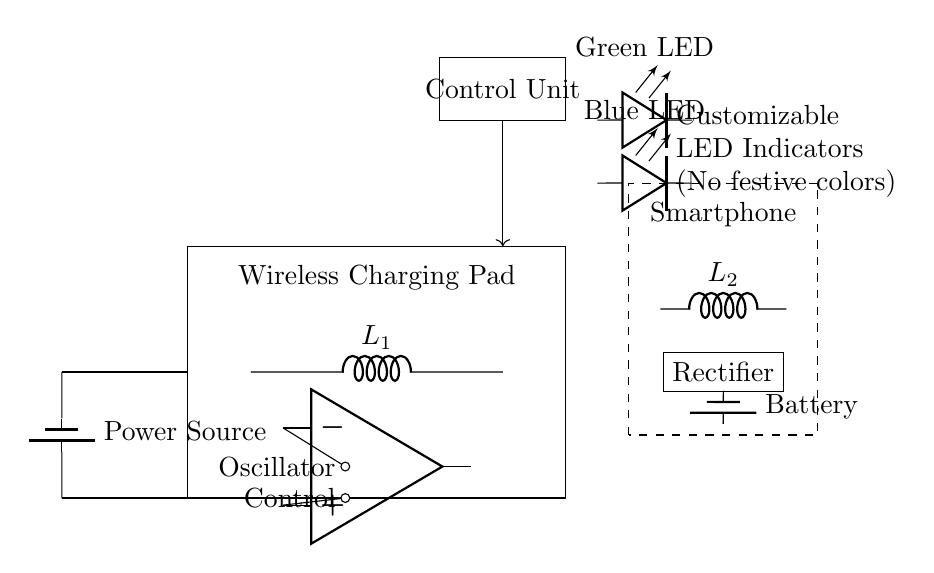What is the main function of the wireless charging pad? The function is to transfer energy wirelessly to charge a smartphone using inductive coupling through the coils.
Answer: Transfer energy wirelessly What components make up the charging pad? The charging pad consists of a power source, oscillator, transmitting coil, and a control unit to manage the charging process.
Answer: Power source, oscillator, coil, control unit How many LED indicators are present in the circuit? There are two LED indicators in the circuit, specifically labeled as green and blue.
Answer: Two LED indicators What type of battery is shown in the circuit? The circuit diagram indicates a rechargeable battery, usually used for smartphone applications, with no explicit voltage mentioned.
Answer: Rechargeable battery What color are the LED indicators designed to be? The LED indicators are custom-made for green and blue colors, avoiding traditional festive colors like red and gold.
Answer: Green and blue Explain the role of the rectifier in this circuit. The rectifier converts the alternating current induced in the receiver coil (due to the wireless charging) to direct current, which is suitable for charging the smartphone's battery.
Answer: Converts AC to DC Which component controls the power flow to the smartphone? The control unit is responsible for managing the power flow by regulating the output based on the smartphone's charging needs, ensuring efficiency and safety.
Answer: Control unit 